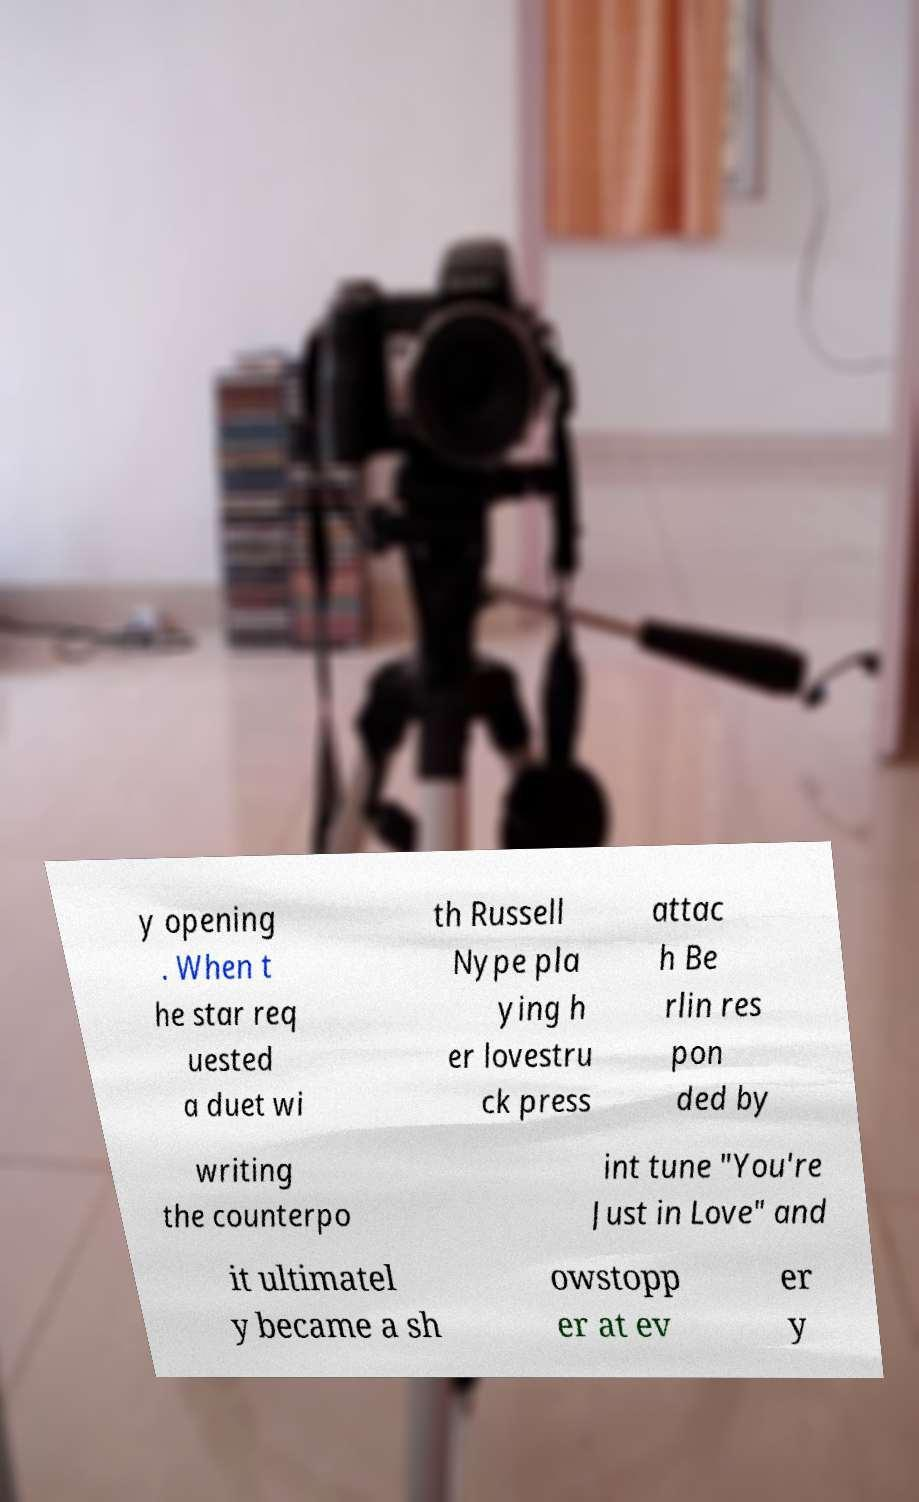Can you accurately transcribe the text from the provided image for me? y opening . When t he star req uested a duet wi th Russell Nype pla ying h er lovestru ck press attac h Be rlin res pon ded by writing the counterpo int tune "You're Just in Love" and it ultimatel y became a sh owstopp er at ev er y 